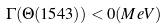Convert formula to latex. <formula><loc_0><loc_0><loc_500><loc_500>\Gamma ( \Theta ( 1 5 4 3 ) ) < 0 ( M e V )</formula> 